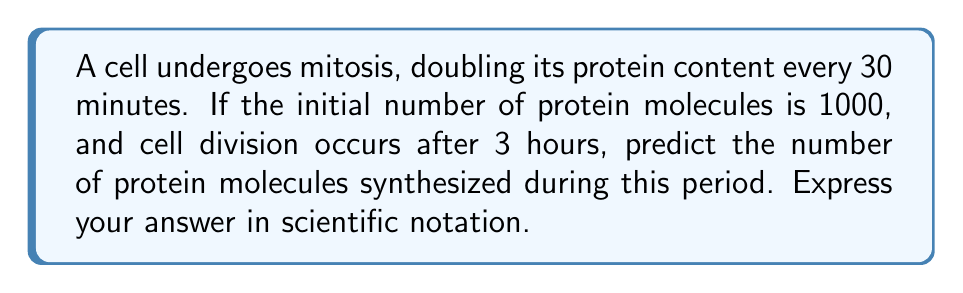Show me your answer to this math problem. Let's approach this step-by-step:

1) First, we need to determine how many times the protein content doubles in 3 hours:
   - 3 hours = 180 minutes
   - Number of doublings = 180 minutes ÷ 30 minutes = 6 doublings

2) Now, we can use the exponential growth formula:
   $$ N = N_0 \cdot 2^n $$
   Where:
   $N$ = Final number of protein molecules
   $N_0$ = Initial number of protein molecules (1000)
   $n$ = Number of doublings (6)

3) Plugging in the values:
   $$ N = 1000 \cdot 2^6 $$

4) Let's calculate:
   $$ N = 1000 \cdot 64 = 64,000 $$

5) To find the number of proteins synthesized, we subtract the initial number:
   $$ \text{Proteins synthesized} = 64,000 - 1000 = 63,000 $$

6) Express in scientific notation:
   $$ 63,000 = 6.3 \times 10^4 $$
Answer: $6.3 \times 10^4$ 